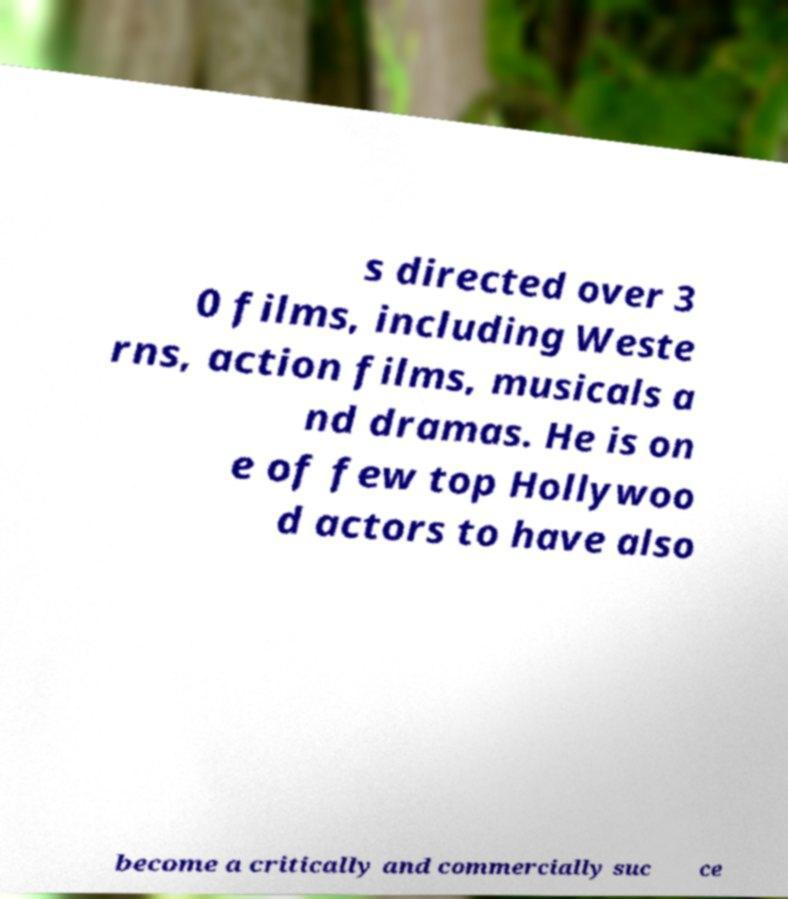I need the written content from this picture converted into text. Can you do that? s directed over 3 0 films, including Weste rns, action films, musicals a nd dramas. He is on e of few top Hollywoo d actors to have also become a critically and commercially suc ce 